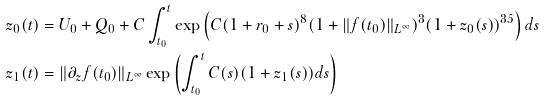<formula> <loc_0><loc_0><loc_500><loc_500>z _ { 0 } ( t ) & = U _ { 0 } + Q _ { 0 } + C \int _ { t _ { 0 } } ^ { t } \exp \left ( C ( 1 + r _ { 0 } + s ) ^ { 8 } ( 1 + \| f ( t _ { 0 } ) \| _ { L ^ { \infty } } ) ^ { 3 } ( 1 + z _ { 0 } ( s ) ) ^ { 3 5 } \right ) d s \\ z _ { 1 } ( t ) & = \| \partial _ { z } f ( t _ { 0 } ) \| _ { L ^ { \infty } } \exp \left ( \int _ { t _ { 0 } } ^ { t } C ( s ) ( 1 + z _ { 1 } ( s ) ) d s \right )</formula> 